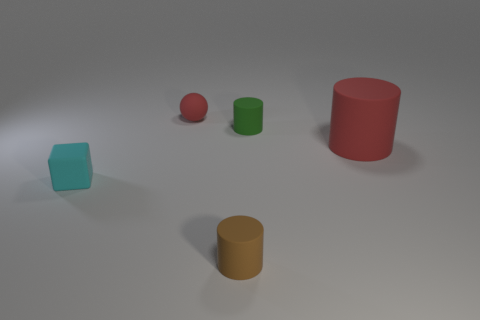Add 4 cylinders. How many objects exist? 9 Subtract all small cylinders. How many cylinders are left? 1 Subtract all blocks. How many objects are left? 4 Subtract 1 blocks. How many blocks are left? 0 Subtract all red spheres. How many brown cylinders are left? 1 Subtract all tiny red spheres. Subtract all small cyan blocks. How many objects are left? 3 Add 3 red rubber balls. How many red rubber balls are left? 4 Add 5 rubber blocks. How many rubber blocks exist? 6 Subtract 0 purple balls. How many objects are left? 5 Subtract all purple cylinders. Subtract all blue blocks. How many cylinders are left? 3 